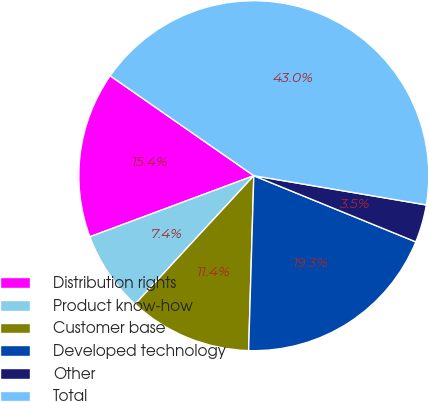Convert chart to OTSL. <chart><loc_0><loc_0><loc_500><loc_500><pie_chart><fcel>Distribution rights<fcel>Product know-how<fcel>Customer base<fcel>Developed technology<fcel>Other<fcel>Total<nl><fcel>15.35%<fcel>7.45%<fcel>11.4%<fcel>19.3%<fcel>3.5%<fcel>43.0%<nl></chart> 